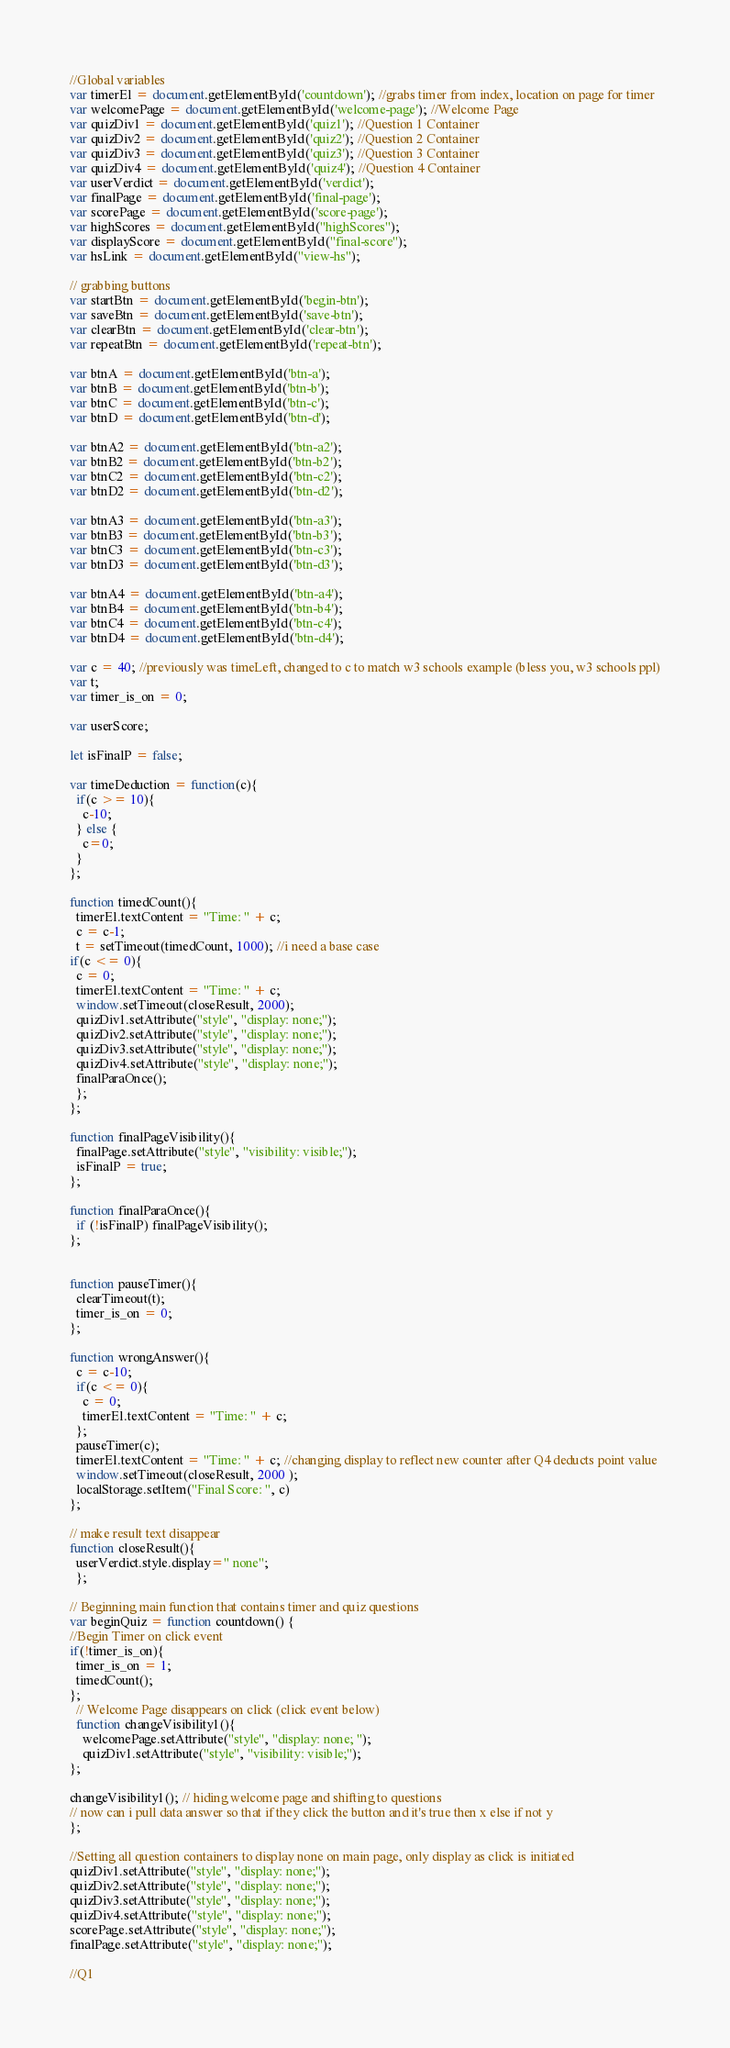Convert code to text. <code><loc_0><loc_0><loc_500><loc_500><_JavaScript_>//Global variables
var timerEl = document.getElementById('countdown'); //grabs timer from index, location on page for timer
var welcomePage = document.getElementById('welcome-page'); //Welcome Page
var quizDiv1 = document.getElementById('quiz1'); //Question 1 Container
var quizDiv2 = document.getElementById('quiz2'); //Question 2 Container
var quizDiv3 = document.getElementById('quiz3'); //Question 3 Container
var quizDiv4 = document.getElementById('quiz4'); //Question 4 Container
var userVerdict = document.getElementById('verdict');
var finalPage = document.getElementById('final-page');
var scorePage = document.getElementById('score-page');
var highScores = document.getElementById("highScores");
var displayScore = document.getElementById("final-score");
var hsLink = document.getElementById("view-hs");

// grabbing buttons
var startBtn = document.getElementById('begin-btn');
var saveBtn = document.getElementById('save-btn');
var clearBtn = document.getElementById('clear-btn');
var repeatBtn = document.getElementById('repeat-btn');

var btnA = document.getElementById('btn-a');
var btnB = document.getElementById('btn-b');
var btnC = document.getElementById('btn-c');
var btnD = document.getElementById('btn-d');

var btnA2 = document.getElementById('btn-a2');
var btnB2 = document.getElementById('btn-b2');
var btnC2 = document.getElementById('btn-c2');
var btnD2 = document.getElementById('btn-d2');

var btnA3 = document.getElementById('btn-a3');
var btnB3 = document.getElementById('btn-b3');
var btnC3 = document.getElementById('btn-c3');
var btnD3 = document.getElementById('btn-d3');

var btnA4 = document.getElementById('btn-a4');
var btnB4 = document.getElementById('btn-b4');
var btnC4 = document.getElementById('btn-c4');
var btnD4 = document.getElementById('btn-d4');

var c = 40; //previously was timeLeft, changed to c to match w3 schools example (bless you, w3 schools ppl)
var t;
var timer_is_on = 0;

var userScore;

let isFinalP = false;

var timeDeduction = function(c){
  if(c >= 10){
    c-10;
  } else {
    c=0;
  }
};

function timedCount(){
  timerEl.textContent = "Time: " + c;
  c = c-1;
  t = setTimeout(timedCount, 1000); //i need a base case
if(c <= 0){
  c = 0;
  timerEl.textContent = "Time: " + c;
  window.setTimeout(closeResult, 2000);
  quizDiv1.setAttribute("style", "display: none;");
  quizDiv2.setAttribute("style", "display: none;");
  quizDiv3.setAttribute("style", "display: none;");
  quizDiv4.setAttribute("style", "display: none;");
  finalParaOnce();
  };
};

function finalPageVisibility(){
  finalPage.setAttribute("style", "visibility: visible;");
  isFinalP = true;
};

function finalParaOnce(){
  if (!isFinalP) finalPageVisibility();
};


function pauseTimer(){
  clearTimeout(t);
  timer_is_on = 0;
};

function wrongAnswer(){
  c = c-10;
  if(c <= 0){
    c = 0;
    timerEl.textContent = "Time: " + c;
  };
  pauseTimer(c);
  timerEl.textContent = "Time: " + c; //changing display to reflect new counter after Q4 deducts point value
  window.setTimeout(closeResult, 2000 );
  localStorage.setItem("Final Score: ", c)
};

// make result text disappear
function closeResult(){
  userVerdict.style.display=" none";
  };

// Beginning main function that contains timer and quiz questions
var beginQuiz = function countdown() {
//Begin Timer on click event
if(!timer_is_on){
  timer_is_on = 1;
  timedCount();
};
  // Welcome Page disappears on click (click event below)
  function changeVisibility1(){
    welcomePage.setAttribute("style", "display: none; ");
    quizDiv1.setAttribute("style", "visibility: visible;");
};

changeVisibility1(); // hiding welcome page and shifting to questions
// now can i pull data answer so that if they click the button and it's true then x else if not y
};

//Setting all question containers to display none on main page, only display as click is initiated
quizDiv1.setAttribute("style", "display: none;");
quizDiv2.setAttribute("style", "display: none;");
quizDiv3.setAttribute("style", "display: none;");
quizDiv4.setAttribute("style", "display: none;");
scorePage.setAttribute("style", "display: none;");
finalPage.setAttribute("style", "display: none;");

//Q1</code> 